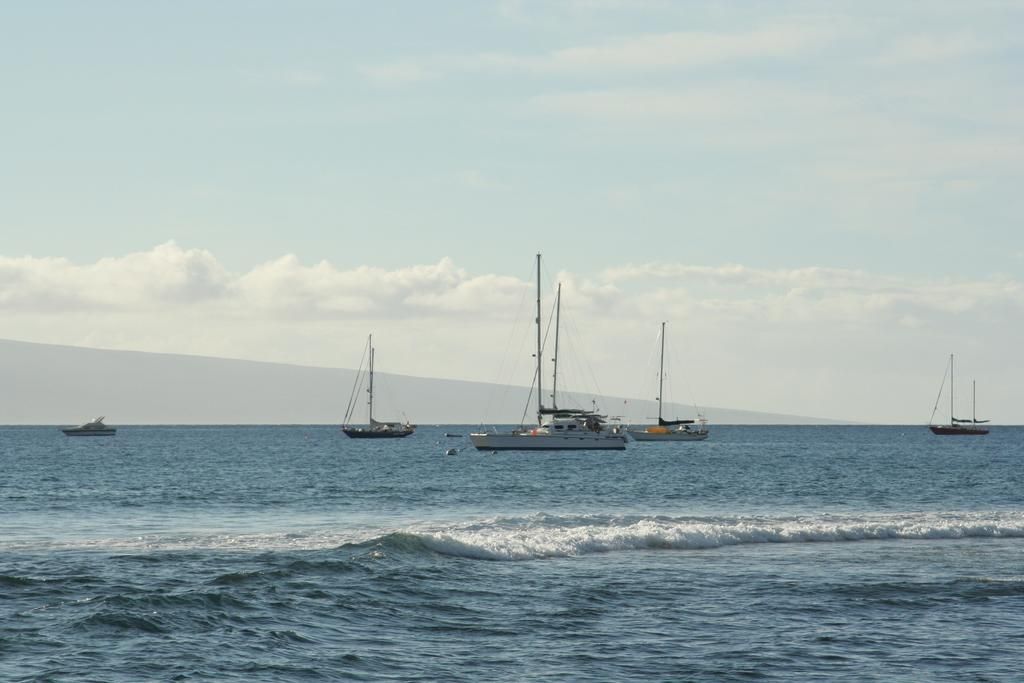What type of vehicles are in the image? There are boats in the image. What color are the boats? The boats are white in color. What is the primary element surrounding the boats? There is water in the image. What can be seen in the background of the image? The sky is visible in the background. What colors are present in the sky? The sky has blue and white colors. How many chairs are placed in the bedroom in the image? There is no bedroom or chairs present in the image; it features boats on water with a blue and white sky in the background. 